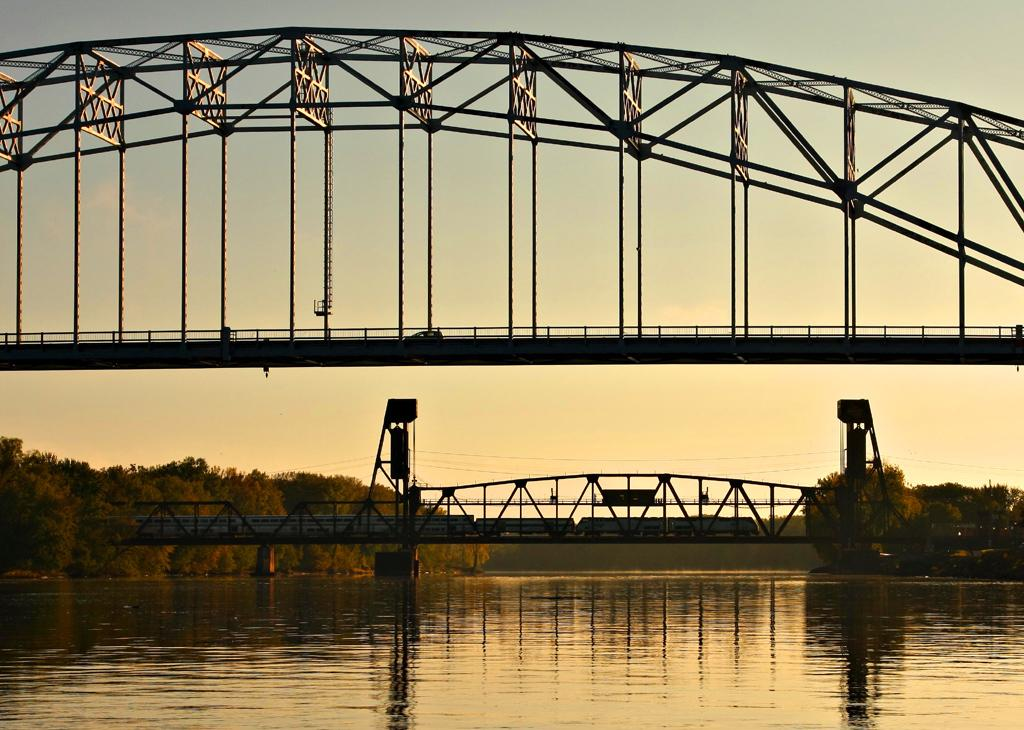What is at the bottom of the image? There is water at the bottom of the image. What structures can be seen in the image? There are bridges in the image. What type of vegetation is visible in the background of the image? There are trees in the background of the image. What part of the natural environment is visible in the image? The sky is visible in the background of the image. What type of game is being played on the water in the image? There is no game being played on the water in the image; it is simply a body of water. What objects are being stretched across the water in the image? There are no objects being stretched across the water in the image; the structures present are bridges. 